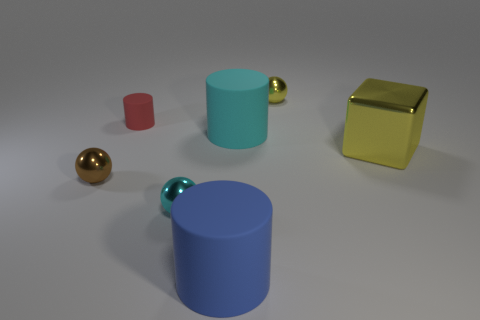Add 2 tiny yellow metallic objects. How many objects exist? 9 Subtract all spheres. How many objects are left? 4 Subtract 1 cyan balls. How many objects are left? 6 Subtract all large metallic blocks. Subtract all green metallic objects. How many objects are left? 6 Add 3 cyan objects. How many cyan objects are left? 5 Add 3 large objects. How many large objects exist? 6 